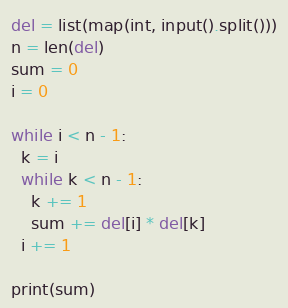<code> <loc_0><loc_0><loc_500><loc_500><_Python_>del = list(map(int, input().split()))
n = len(del)
sum = 0
i = 0

while i < n - 1:
  k = i
  while k < n - 1:
    k += 1
    sum += del[i] * del[k]
  i += 1
  
print(sum)

</code> 